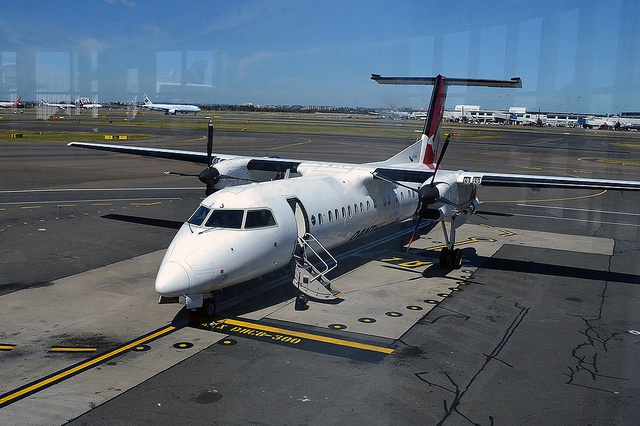Describe the objects in this image and their specific colors. I can see airplane in gray, lightgray, black, and darkgray tones, airplane in gray, lightgray, lightblue, and black tones, airplane in gray, lightgray, darkgray, and black tones, airplane in gray, black, and darkgray tones, and airplane in gray, black, and darkgray tones in this image. 